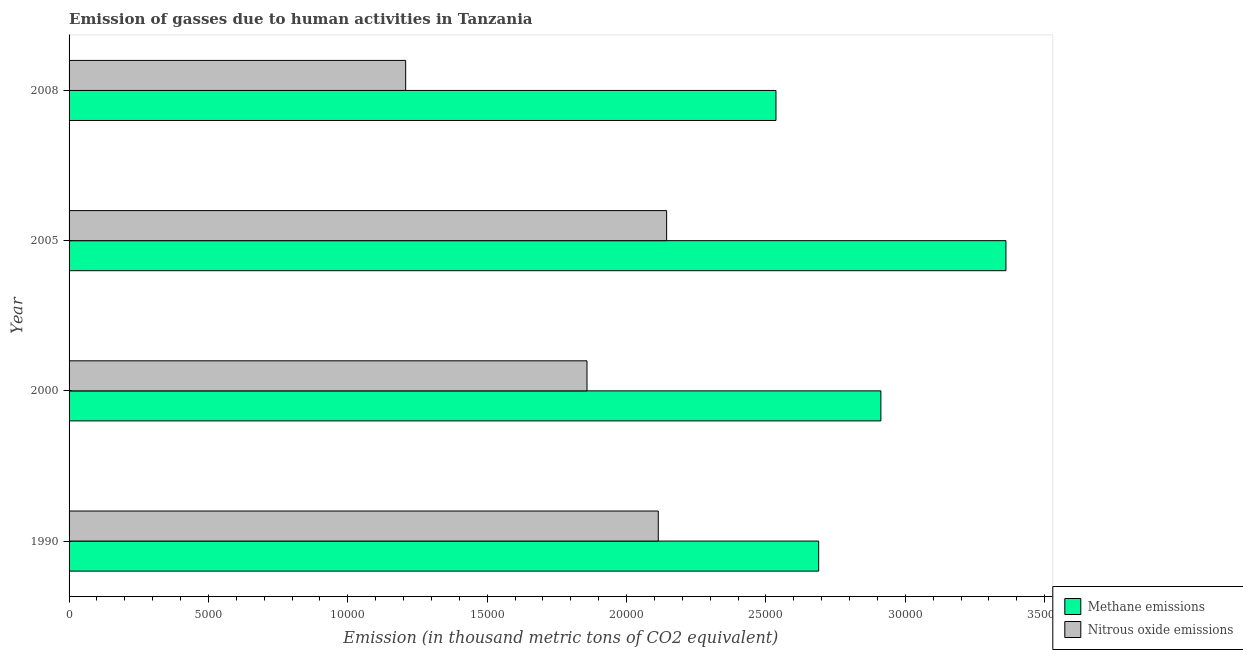How many different coloured bars are there?
Make the answer very short. 2. Are the number of bars per tick equal to the number of legend labels?
Offer a terse response. Yes. In how many cases, is the number of bars for a given year not equal to the number of legend labels?
Provide a succinct answer. 0. What is the amount of methane emissions in 1990?
Offer a terse response. 2.69e+04. Across all years, what is the maximum amount of nitrous oxide emissions?
Your response must be concise. 2.14e+04. Across all years, what is the minimum amount of nitrous oxide emissions?
Provide a succinct answer. 1.21e+04. In which year was the amount of nitrous oxide emissions maximum?
Keep it short and to the point. 2005. In which year was the amount of methane emissions minimum?
Your response must be concise. 2008. What is the total amount of nitrous oxide emissions in the graph?
Your answer should be very brief. 7.32e+04. What is the difference between the amount of methane emissions in 1990 and that in 2005?
Provide a succinct answer. -6719. What is the difference between the amount of methane emissions in 2005 and the amount of nitrous oxide emissions in 1990?
Offer a very short reply. 1.25e+04. What is the average amount of methane emissions per year?
Keep it short and to the point. 2.87e+04. In the year 2000, what is the difference between the amount of nitrous oxide emissions and amount of methane emissions?
Offer a very short reply. -1.05e+04. Is the amount of methane emissions in 2005 less than that in 2008?
Give a very brief answer. No. What is the difference between the highest and the second highest amount of nitrous oxide emissions?
Your response must be concise. 300.2. What is the difference between the highest and the lowest amount of methane emissions?
Your answer should be very brief. 8250.3. In how many years, is the amount of nitrous oxide emissions greater than the average amount of nitrous oxide emissions taken over all years?
Provide a short and direct response. 3. Is the sum of the amount of methane emissions in 2000 and 2005 greater than the maximum amount of nitrous oxide emissions across all years?
Provide a short and direct response. Yes. What does the 1st bar from the top in 1990 represents?
Give a very brief answer. Nitrous oxide emissions. What does the 2nd bar from the bottom in 2008 represents?
Give a very brief answer. Nitrous oxide emissions. What is the difference between two consecutive major ticks on the X-axis?
Ensure brevity in your answer.  5000. Are the values on the major ticks of X-axis written in scientific E-notation?
Your response must be concise. No. Does the graph contain grids?
Ensure brevity in your answer.  No. How many legend labels are there?
Your response must be concise. 2. What is the title of the graph?
Provide a short and direct response. Emission of gasses due to human activities in Tanzania. What is the label or title of the X-axis?
Make the answer very short. Emission (in thousand metric tons of CO2 equivalent). What is the Emission (in thousand metric tons of CO2 equivalent) in Methane emissions in 1990?
Your answer should be compact. 2.69e+04. What is the Emission (in thousand metric tons of CO2 equivalent) of Nitrous oxide emissions in 1990?
Make the answer very short. 2.11e+04. What is the Emission (in thousand metric tons of CO2 equivalent) of Methane emissions in 2000?
Offer a very short reply. 2.91e+04. What is the Emission (in thousand metric tons of CO2 equivalent) of Nitrous oxide emissions in 2000?
Make the answer very short. 1.86e+04. What is the Emission (in thousand metric tons of CO2 equivalent) of Methane emissions in 2005?
Your response must be concise. 3.36e+04. What is the Emission (in thousand metric tons of CO2 equivalent) of Nitrous oxide emissions in 2005?
Offer a very short reply. 2.14e+04. What is the Emission (in thousand metric tons of CO2 equivalent) in Methane emissions in 2008?
Offer a terse response. 2.54e+04. What is the Emission (in thousand metric tons of CO2 equivalent) of Nitrous oxide emissions in 2008?
Make the answer very short. 1.21e+04. Across all years, what is the maximum Emission (in thousand metric tons of CO2 equivalent) in Methane emissions?
Offer a very short reply. 3.36e+04. Across all years, what is the maximum Emission (in thousand metric tons of CO2 equivalent) of Nitrous oxide emissions?
Give a very brief answer. 2.14e+04. Across all years, what is the minimum Emission (in thousand metric tons of CO2 equivalent) in Methane emissions?
Your answer should be compact. 2.54e+04. Across all years, what is the minimum Emission (in thousand metric tons of CO2 equivalent) in Nitrous oxide emissions?
Keep it short and to the point. 1.21e+04. What is the total Emission (in thousand metric tons of CO2 equivalent) in Methane emissions in the graph?
Your answer should be very brief. 1.15e+05. What is the total Emission (in thousand metric tons of CO2 equivalent) in Nitrous oxide emissions in the graph?
Your answer should be very brief. 7.32e+04. What is the difference between the Emission (in thousand metric tons of CO2 equivalent) of Methane emissions in 1990 and that in 2000?
Your response must be concise. -2232.7. What is the difference between the Emission (in thousand metric tons of CO2 equivalent) in Nitrous oxide emissions in 1990 and that in 2000?
Ensure brevity in your answer.  2557. What is the difference between the Emission (in thousand metric tons of CO2 equivalent) in Methane emissions in 1990 and that in 2005?
Keep it short and to the point. -6719. What is the difference between the Emission (in thousand metric tons of CO2 equivalent) in Nitrous oxide emissions in 1990 and that in 2005?
Keep it short and to the point. -300.2. What is the difference between the Emission (in thousand metric tons of CO2 equivalent) of Methane emissions in 1990 and that in 2008?
Make the answer very short. 1531.3. What is the difference between the Emission (in thousand metric tons of CO2 equivalent) in Nitrous oxide emissions in 1990 and that in 2008?
Your answer should be very brief. 9061.6. What is the difference between the Emission (in thousand metric tons of CO2 equivalent) in Methane emissions in 2000 and that in 2005?
Give a very brief answer. -4486.3. What is the difference between the Emission (in thousand metric tons of CO2 equivalent) in Nitrous oxide emissions in 2000 and that in 2005?
Your response must be concise. -2857.2. What is the difference between the Emission (in thousand metric tons of CO2 equivalent) in Methane emissions in 2000 and that in 2008?
Offer a terse response. 3764. What is the difference between the Emission (in thousand metric tons of CO2 equivalent) of Nitrous oxide emissions in 2000 and that in 2008?
Your answer should be compact. 6504.6. What is the difference between the Emission (in thousand metric tons of CO2 equivalent) of Methane emissions in 2005 and that in 2008?
Offer a terse response. 8250.3. What is the difference between the Emission (in thousand metric tons of CO2 equivalent) in Nitrous oxide emissions in 2005 and that in 2008?
Keep it short and to the point. 9361.8. What is the difference between the Emission (in thousand metric tons of CO2 equivalent) of Methane emissions in 1990 and the Emission (in thousand metric tons of CO2 equivalent) of Nitrous oxide emissions in 2000?
Your response must be concise. 8310.7. What is the difference between the Emission (in thousand metric tons of CO2 equivalent) in Methane emissions in 1990 and the Emission (in thousand metric tons of CO2 equivalent) in Nitrous oxide emissions in 2005?
Your response must be concise. 5453.5. What is the difference between the Emission (in thousand metric tons of CO2 equivalent) in Methane emissions in 1990 and the Emission (in thousand metric tons of CO2 equivalent) in Nitrous oxide emissions in 2008?
Provide a short and direct response. 1.48e+04. What is the difference between the Emission (in thousand metric tons of CO2 equivalent) in Methane emissions in 2000 and the Emission (in thousand metric tons of CO2 equivalent) in Nitrous oxide emissions in 2005?
Offer a terse response. 7686.2. What is the difference between the Emission (in thousand metric tons of CO2 equivalent) of Methane emissions in 2000 and the Emission (in thousand metric tons of CO2 equivalent) of Nitrous oxide emissions in 2008?
Provide a succinct answer. 1.70e+04. What is the difference between the Emission (in thousand metric tons of CO2 equivalent) in Methane emissions in 2005 and the Emission (in thousand metric tons of CO2 equivalent) in Nitrous oxide emissions in 2008?
Provide a succinct answer. 2.15e+04. What is the average Emission (in thousand metric tons of CO2 equivalent) in Methane emissions per year?
Give a very brief answer. 2.87e+04. What is the average Emission (in thousand metric tons of CO2 equivalent) of Nitrous oxide emissions per year?
Offer a very short reply. 1.83e+04. In the year 1990, what is the difference between the Emission (in thousand metric tons of CO2 equivalent) in Methane emissions and Emission (in thousand metric tons of CO2 equivalent) in Nitrous oxide emissions?
Provide a succinct answer. 5753.7. In the year 2000, what is the difference between the Emission (in thousand metric tons of CO2 equivalent) in Methane emissions and Emission (in thousand metric tons of CO2 equivalent) in Nitrous oxide emissions?
Offer a terse response. 1.05e+04. In the year 2005, what is the difference between the Emission (in thousand metric tons of CO2 equivalent) in Methane emissions and Emission (in thousand metric tons of CO2 equivalent) in Nitrous oxide emissions?
Offer a very short reply. 1.22e+04. In the year 2008, what is the difference between the Emission (in thousand metric tons of CO2 equivalent) in Methane emissions and Emission (in thousand metric tons of CO2 equivalent) in Nitrous oxide emissions?
Provide a short and direct response. 1.33e+04. What is the ratio of the Emission (in thousand metric tons of CO2 equivalent) of Methane emissions in 1990 to that in 2000?
Your answer should be compact. 0.92. What is the ratio of the Emission (in thousand metric tons of CO2 equivalent) in Nitrous oxide emissions in 1990 to that in 2000?
Ensure brevity in your answer.  1.14. What is the ratio of the Emission (in thousand metric tons of CO2 equivalent) of Methane emissions in 1990 to that in 2005?
Your answer should be very brief. 0.8. What is the ratio of the Emission (in thousand metric tons of CO2 equivalent) of Methane emissions in 1990 to that in 2008?
Offer a terse response. 1.06. What is the ratio of the Emission (in thousand metric tons of CO2 equivalent) of Nitrous oxide emissions in 1990 to that in 2008?
Your answer should be compact. 1.75. What is the ratio of the Emission (in thousand metric tons of CO2 equivalent) in Methane emissions in 2000 to that in 2005?
Offer a terse response. 0.87. What is the ratio of the Emission (in thousand metric tons of CO2 equivalent) in Nitrous oxide emissions in 2000 to that in 2005?
Keep it short and to the point. 0.87. What is the ratio of the Emission (in thousand metric tons of CO2 equivalent) in Methane emissions in 2000 to that in 2008?
Provide a short and direct response. 1.15. What is the ratio of the Emission (in thousand metric tons of CO2 equivalent) in Nitrous oxide emissions in 2000 to that in 2008?
Make the answer very short. 1.54. What is the ratio of the Emission (in thousand metric tons of CO2 equivalent) in Methane emissions in 2005 to that in 2008?
Provide a short and direct response. 1.33. What is the ratio of the Emission (in thousand metric tons of CO2 equivalent) of Nitrous oxide emissions in 2005 to that in 2008?
Make the answer very short. 1.78. What is the difference between the highest and the second highest Emission (in thousand metric tons of CO2 equivalent) in Methane emissions?
Ensure brevity in your answer.  4486.3. What is the difference between the highest and the second highest Emission (in thousand metric tons of CO2 equivalent) in Nitrous oxide emissions?
Your answer should be compact. 300.2. What is the difference between the highest and the lowest Emission (in thousand metric tons of CO2 equivalent) in Methane emissions?
Your response must be concise. 8250.3. What is the difference between the highest and the lowest Emission (in thousand metric tons of CO2 equivalent) in Nitrous oxide emissions?
Your answer should be compact. 9361.8. 